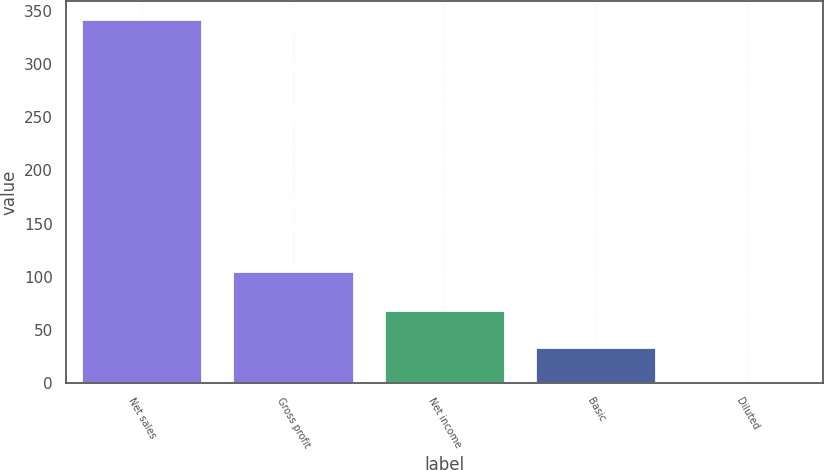Convert chart. <chart><loc_0><loc_0><loc_500><loc_500><bar_chart><fcel>Net sales<fcel>Gross profit<fcel>Net income<fcel>Basic<fcel>Diluted<nl><fcel>341.8<fcel>105.5<fcel>68.65<fcel>34.51<fcel>0.37<nl></chart> 